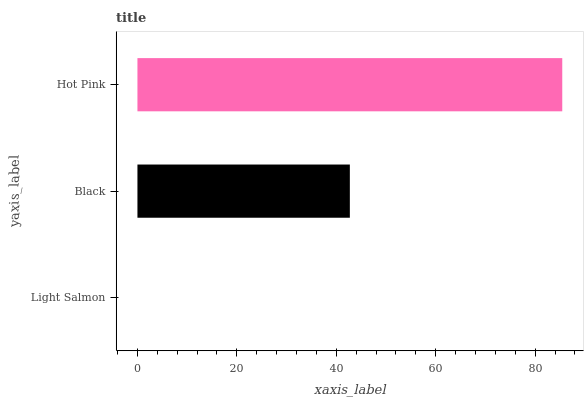Is Light Salmon the minimum?
Answer yes or no. Yes. Is Hot Pink the maximum?
Answer yes or no. Yes. Is Black the minimum?
Answer yes or no. No. Is Black the maximum?
Answer yes or no. No. Is Black greater than Light Salmon?
Answer yes or no. Yes. Is Light Salmon less than Black?
Answer yes or no. Yes. Is Light Salmon greater than Black?
Answer yes or no. No. Is Black less than Light Salmon?
Answer yes or no. No. Is Black the high median?
Answer yes or no. Yes. Is Black the low median?
Answer yes or no. Yes. Is Light Salmon the high median?
Answer yes or no. No. Is Hot Pink the low median?
Answer yes or no. No. 